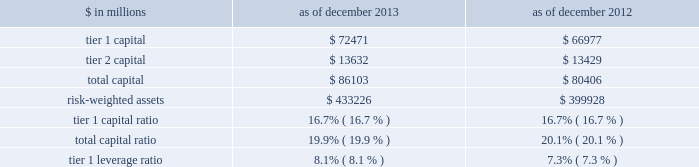Notes to consolidated financial statements the table below presents information regarding group inc . 2019s regulatory capital ratios and tier 1 leverage ratio under basel i , as implemented by the federal reserve board .
The information as of december 2013 reflects the revised market risk regulatory capital requirements .
These changes resulted in increased regulatory capital requirements for market risk .
The information as of december 2012 is prior to the implementation of these revised market risk regulatory capital requirements. .
Revised capital framework the u.s .
Federal bank regulatory agencies ( agencies ) have approved revised risk-based capital and leverage ratio regulations establishing a new comprehensive capital framework for u.s .
Banking organizations ( revised capital framework ) .
These regulations are largely based on the basel committee 2019s december 2010 final capital framework for strengthening international capital standards ( basel iii ) and also implement certain provisions of the dodd-frank act .
Under the revised capital framework , group inc .
Is an 201cadvanced approach 201d banking organization .
Below are the aspects of the rules that are most relevant to the firm , as an advanced approach banking organization .
Definition of capital and capital ratios .
The revised capital framework introduced changes to the definition of regulatory capital , which , subject to transitional provisions , became effective across the firm 2019s regulatory capital and leverage ratios on january 1 , 2014 .
These changes include the introduction of a new capital measure called common equity tier 1 ( cet1 ) , and the related regulatory capital ratio of cet1 to rwas ( cet1 ratio ) .
In addition , the definition of tier 1 capital has been narrowed to include only cet1 and instruments such as perpetual non- cumulative preferred stock , which meet certain criteria .
Certain aspects of the revised requirements phase in over time .
These include increases in the minimum capital ratio requirements and the introduction of new capital buffers and certain deductions from regulatory capital ( such as investments in nonconsolidated financial institutions ) .
In addition , junior subordinated debt issued to trusts is being phased out of regulatory capital .
The minimum cet1 ratio is 4.0% ( 4.0 % ) as of january 1 , 2014 and will increase to 4.5% ( 4.5 % ) on january 1 , 2015 .
The minimum tier 1 capital ratio increased from 4.0% ( 4.0 % ) to 5.5% ( 5.5 % ) on january 1 , 2014 and will increase to 6.0% ( 6.0 % ) beginning january 1 , 2015 .
The minimum total capital ratio remains unchanged at 8.0% ( 8.0 % ) .
These minimum ratios will be supplemented by a new capital conservation buffer that phases in , beginning january 1 , 2016 , in increments of 0.625% ( 0.625 % ) per year until it reaches 2.5% ( 2.5 % ) on january 1 , 2019 .
The revised capital framework also introduces a new counter-cyclical capital buffer , to be imposed in the event that national supervisors deem it necessary in order to counteract excessive credit growth .
Risk-weighted assets .
In february 2014 , the federal reserve board informed us that we have completed a satisfactory 201cparallel run , 201d as required of advanced approach banking organizations under the revised capital framework , and therefore changes to rwas will take effect beginning with the second quarter of 2014 .
Accordingly , the calculation of rwas in future quarters will be based on the following methodologies : 2030 during the first quarter of 2014 2014 the basel i risk-based capital framework adjusted for certain items related to existing capital deductions and the phase-in of new capital deductions ( basel i adjusted ) ; 2030 during the remaining quarters of 2014 2014 the higher of rwas computed under the basel iii advanced approach or the basel i adjusted calculation ; and 2030 beginning in the first quarter of 2015 2014 the higher of rwas computed under the basel iii advanced or standardized approach .
Goldman sachs 2013 annual report 191 .
In millions for 2013 and 2012 , what was the maximum tier 2 capital? 
Computations: table_max(tier 2 capital, none)
Answer: 13632.0. 